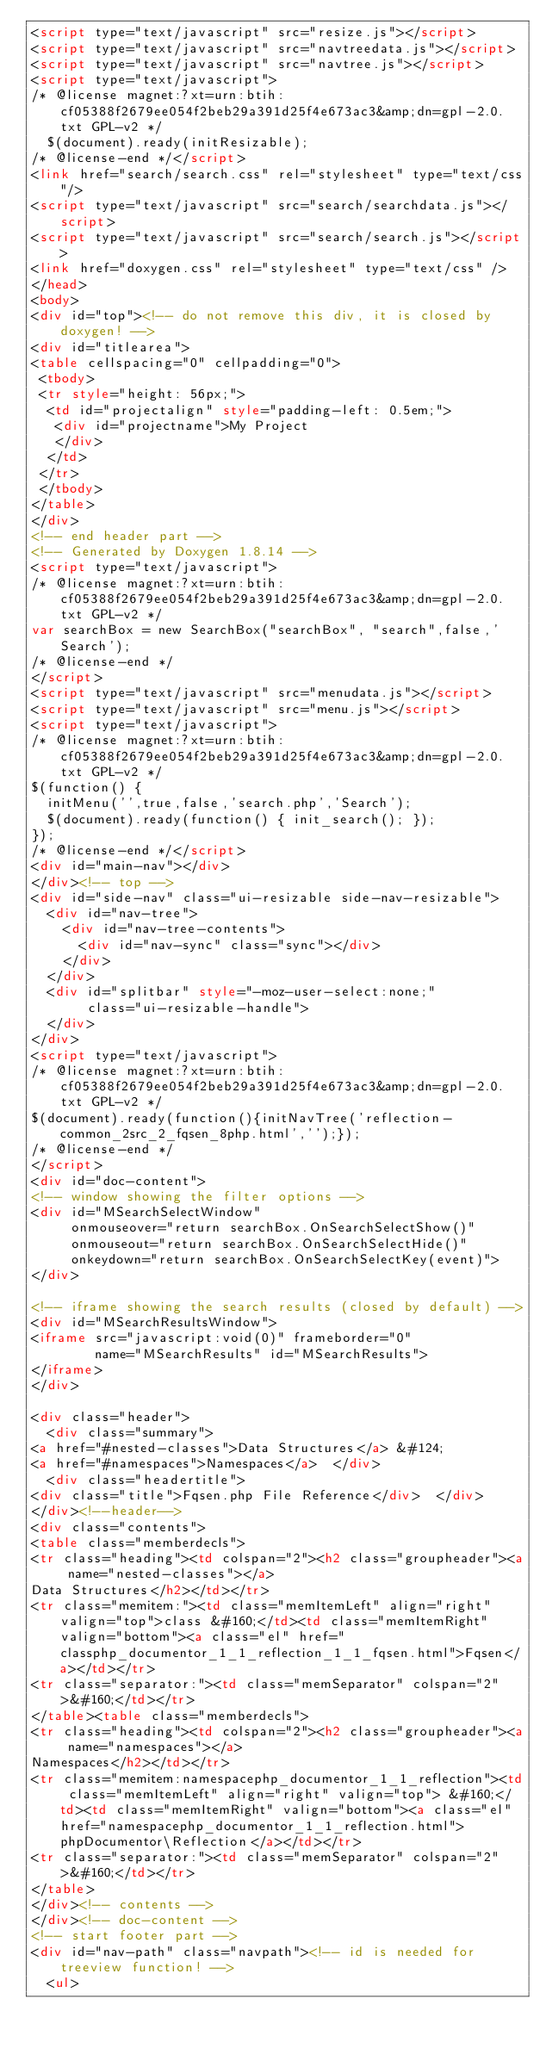Convert code to text. <code><loc_0><loc_0><loc_500><loc_500><_HTML_><script type="text/javascript" src="resize.js"></script>
<script type="text/javascript" src="navtreedata.js"></script>
<script type="text/javascript" src="navtree.js"></script>
<script type="text/javascript">
/* @license magnet:?xt=urn:btih:cf05388f2679ee054f2beb29a391d25f4e673ac3&amp;dn=gpl-2.0.txt GPL-v2 */
  $(document).ready(initResizable);
/* @license-end */</script>
<link href="search/search.css" rel="stylesheet" type="text/css"/>
<script type="text/javascript" src="search/searchdata.js"></script>
<script type="text/javascript" src="search/search.js"></script>
<link href="doxygen.css" rel="stylesheet" type="text/css" />
</head>
<body>
<div id="top"><!-- do not remove this div, it is closed by doxygen! -->
<div id="titlearea">
<table cellspacing="0" cellpadding="0">
 <tbody>
 <tr style="height: 56px;">
  <td id="projectalign" style="padding-left: 0.5em;">
   <div id="projectname">My Project
   </div>
  </td>
 </tr>
 </tbody>
</table>
</div>
<!-- end header part -->
<!-- Generated by Doxygen 1.8.14 -->
<script type="text/javascript">
/* @license magnet:?xt=urn:btih:cf05388f2679ee054f2beb29a391d25f4e673ac3&amp;dn=gpl-2.0.txt GPL-v2 */
var searchBox = new SearchBox("searchBox", "search",false,'Search');
/* @license-end */
</script>
<script type="text/javascript" src="menudata.js"></script>
<script type="text/javascript" src="menu.js"></script>
<script type="text/javascript">
/* @license magnet:?xt=urn:btih:cf05388f2679ee054f2beb29a391d25f4e673ac3&amp;dn=gpl-2.0.txt GPL-v2 */
$(function() {
  initMenu('',true,false,'search.php','Search');
  $(document).ready(function() { init_search(); });
});
/* @license-end */</script>
<div id="main-nav"></div>
</div><!-- top -->
<div id="side-nav" class="ui-resizable side-nav-resizable">
  <div id="nav-tree">
    <div id="nav-tree-contents">
      <div id="nav-sync" class="sync"></div>
    </div>
  </div>
  <div id="splitbar" style="-moz-user-select:none;" 
       class="ui-resizable-handle">
  </div>
</div>
<script type="text/javascript">
/* @license magnet:?xt=urn:btih:cf05388f2679ee054f2beb29a391d25f4e673ac3&amp;dn=gpl-2.0.txt GPL-v2 */
$(document).ready(function(){initNavTree('reflection-common_2src_2_fqsen_8php.html','');});
/* @license-end */
</script>
<div id="doc-content">
<!-- window showing the filter options -->
<div id="MSearchSelectWindow"
     onmouseover="return searchBox.OnSearchSelectShow()"
     onmouseout="return searchBox.OnSearchSelectHide()"
     onkeydown="return searchBox.OnSearchSelectKey(event)">
</div>

<!-- iframe showing the search results (closed by default) -->
<div id="MSearchResultsWindow">
<iframe src="javascript:void(0)" frameborder="0" 
        name="MSearchResults" id="MSearchResults">
</iframe>
</div>

<div class="header">
  <div class="summary">
<a href="#nested-classes">Data Structures</a> &#124;
<a href="#namespaces">Namespaces</a>  </div>
  <div class="headertitle">
<div class="title">Fqsen.php File Reference</div>  </div>
</div><!--header-->
<div class="contents">
<table class="memberdecls">
<tr class="heading"><td colspan="2"><h2 class="groupheader"><a name="nested-classes"></a>
Data Structures</h2></td></tr>
<tr class="memitem:"><td class="memItemLeft" align="right" valign="top">class &#160;</td><td class="memItemRight" valign="bottom"><a class="el" href="classphp_documentor_1_1_reflection_1_1_fqsen.html">Fqsen</a></td></tr>
<tr class="separator:"><td class="memSeparator" colspan="2">&#160;</td></tr>
</table><table class="memberdecls">
<tr class="heading"><td colspan="2"><h2 class="groupheader"><a name="namespaces"></a>
Namespaces</h2></td></tr>
<tr class="memitem:namespacephp_documentor_1_1_reflection"><td class="memItemLeft" align="right" valign="top"> &#160;</td><td class="memItemRight" valign="bottom"><a class="el" href="namespacephp_documentor_1_1_reflection.html">phpDocumentor\Reflection</a></td></tr>
<tr class="separator:"><td class="memSeparator" colspan="2">&#160;</td></tr>
</table>
</div><!-- contents -->
</div><!-- doc-content -->
<!-- start footer part -->
<div id="nav-path" class="navpath"><!-- id is needed for treeview function! -->
  <ul></code> 